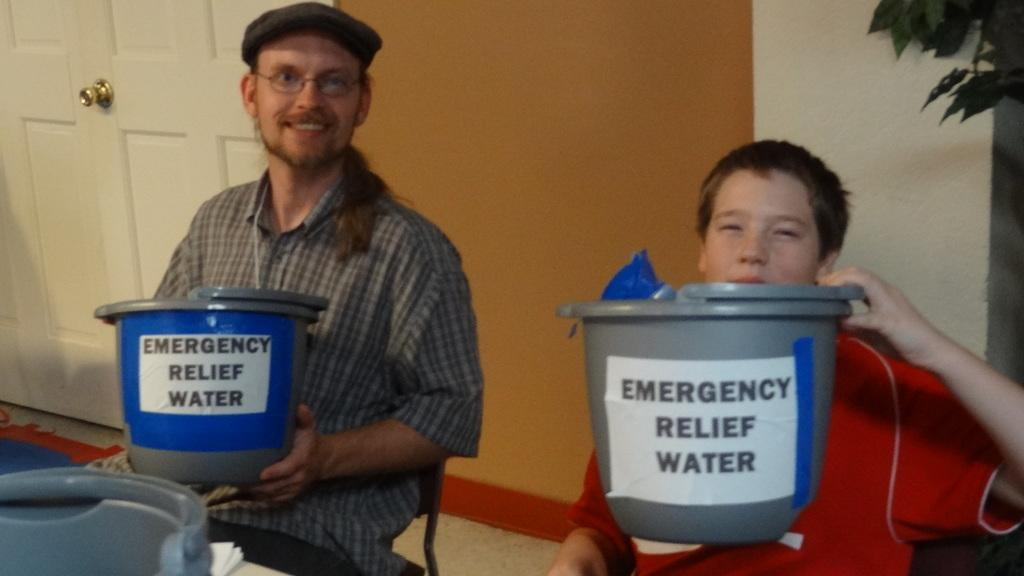<image>
Provide a brief description of the given image. 2 people are holding up buckets that say emergency relief water on them. 